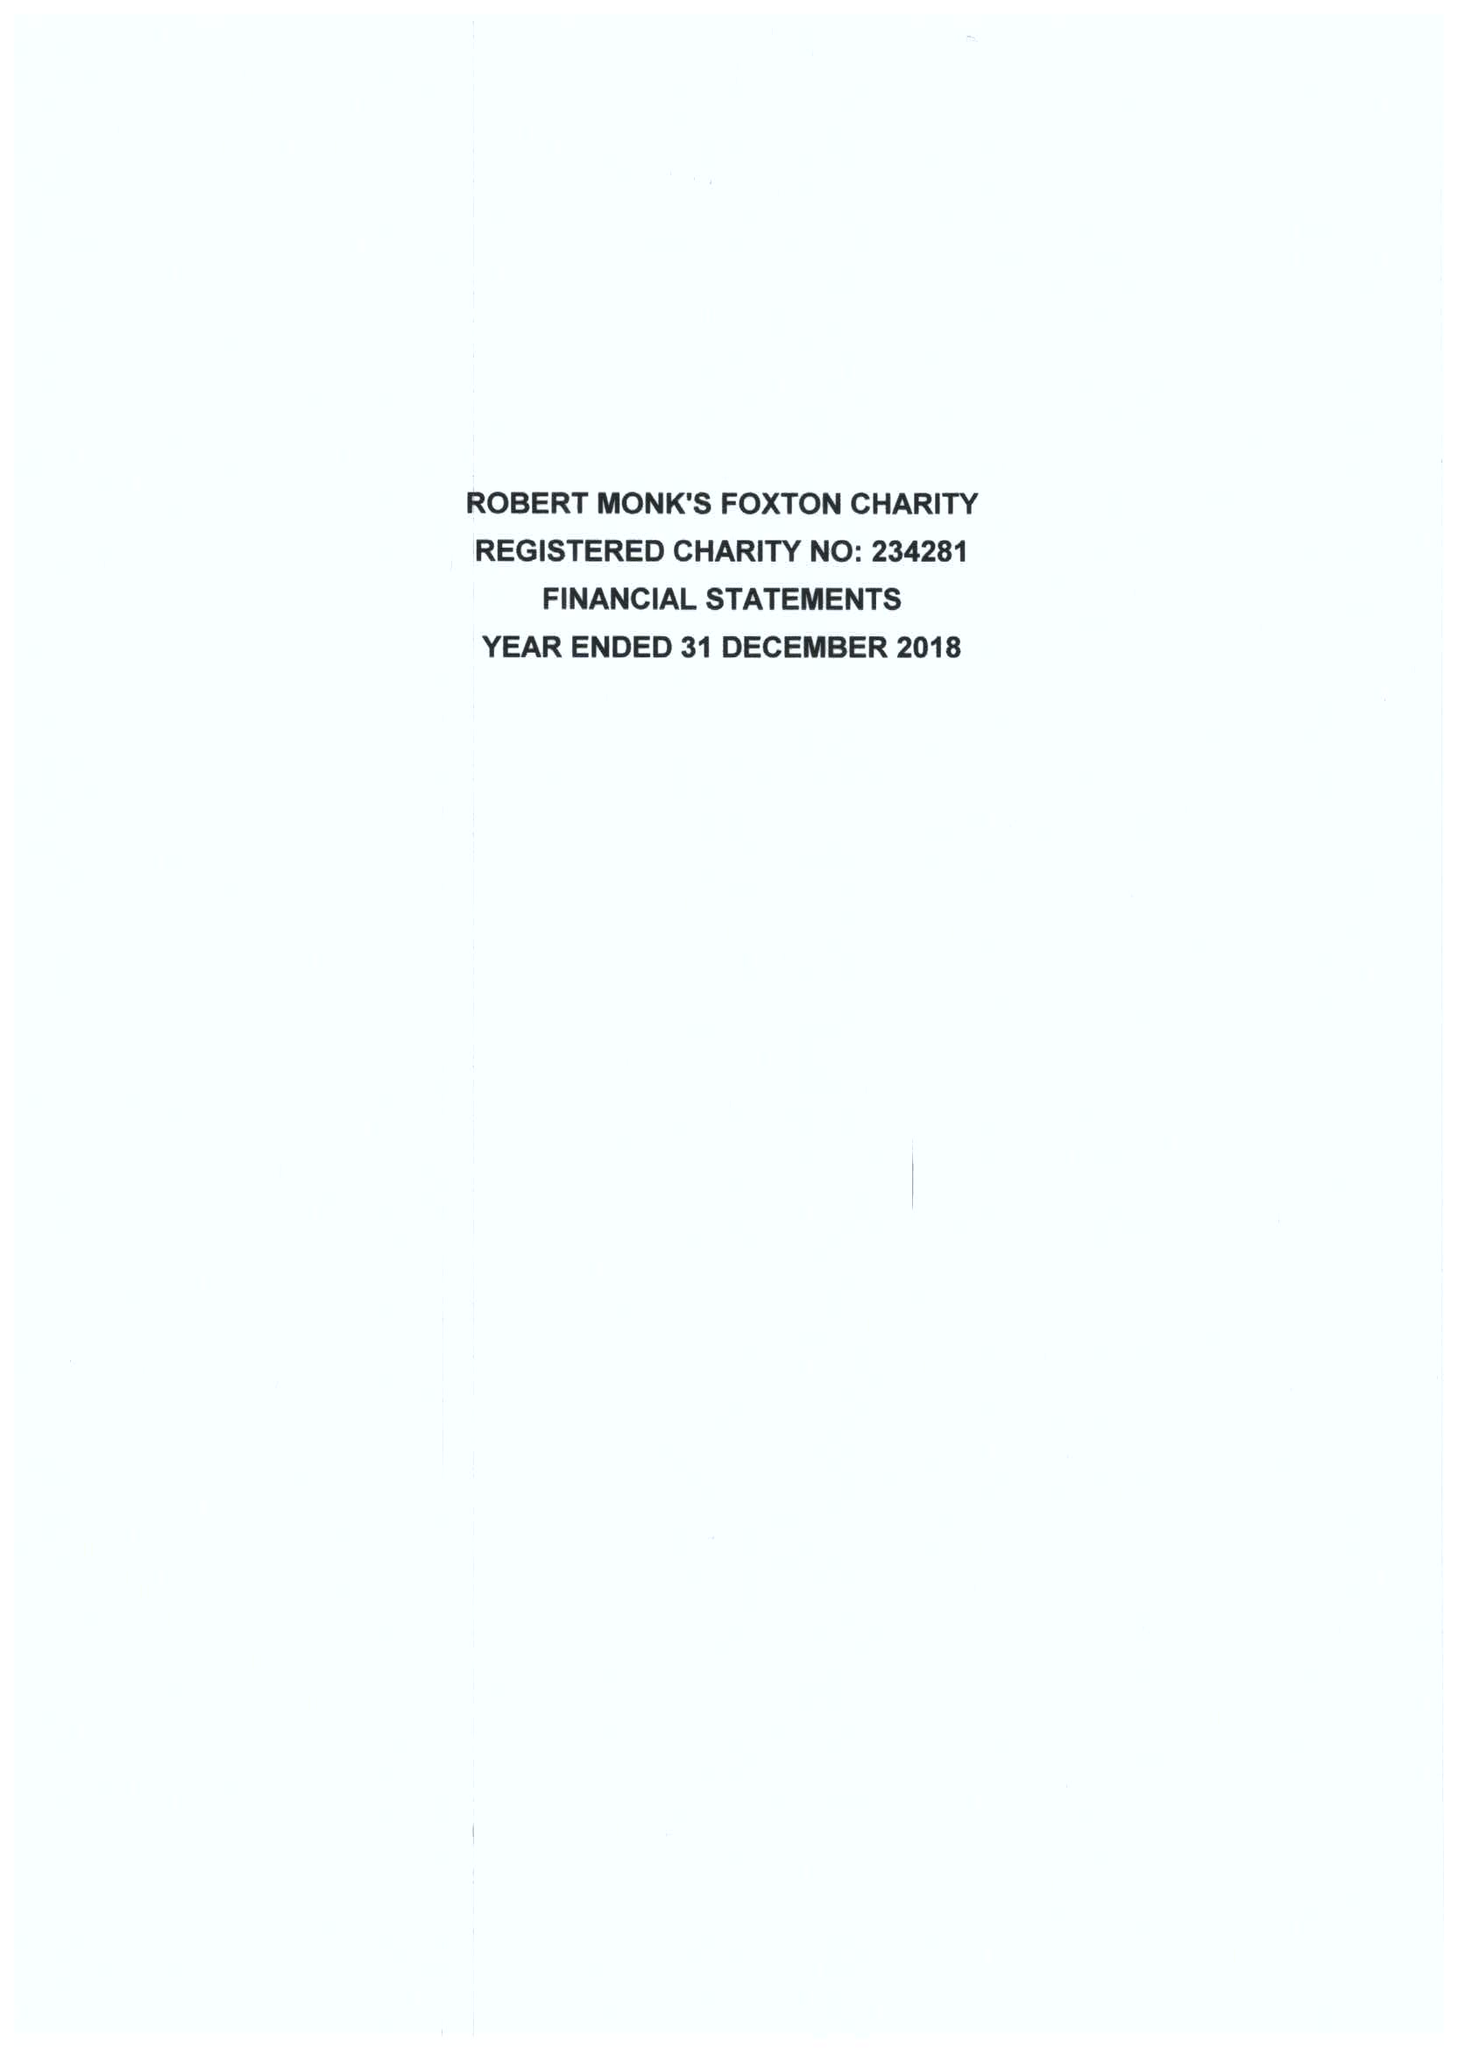What is the value for the report_date?
Answer the question using a single word or phrase. 2018-12-31 